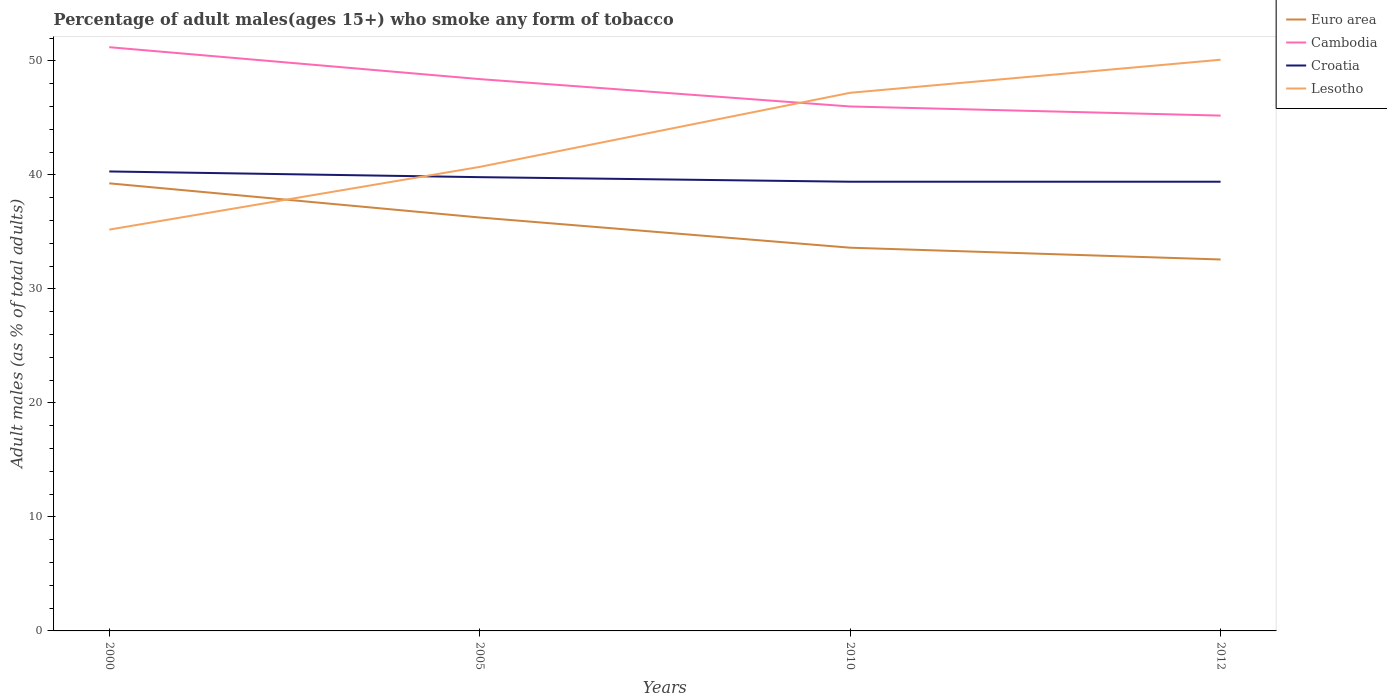Across all years, what is the maximum percentage of adult males who smoke in Croatia?
Offer a very short reply. 39.4. What is the total percentage of adult males who smoke in Cambodia in the graph?
Make the answer very short. 0.8. What is the difference between the highest and the second highest percentage of adult males who smoke in Croatia?
Keep it short and to the point. 0.9. Is the percentage of adult males who smoke in Croatia strictly greater than the percentage of adult males who smoke in Euro area over the years?
Your answer should be very brief. No. How many lines are there?
Ensure brevity in your answer.  4. How many years are there in the graph?
Your answer should be compact. 4. What is the difference between two consecutive major ticks on the Y-axis?
Ensure brevity in your answer.  10. Are the values on the major ticks of Y-axis written in scientific E-notation?
Give a very brief answer. No. How many legend labels are there?
Offer a terse response. 4. What is the title of the graph?
Ensure brevity in your answer.  Percentage of adult males(ages 15+) who smoke any form of tobacco. What is the label or title of the Y-axis?
Offer a terse response. Adult males (as % of total adults). What is the Adult males (as % of total adults) of Euro area in 2000?
Offer a terse response. 39.26. What is the Adult males (as % of total adults) in Cambodia in 2000?
Make the answer very short. 51.2. What is the Adult males (as % of total adults) in Croatia in 2000?
Your answer should be compact. 40.3. What is the Adult males (as % of total adults) of Lesotho in 2000?
Ensure brevity in your answer.  35.2. What is the Adult males (as % of total adults) of Euro area in 2005?
Your answer should be very brief. 36.26. What is the Adult males (as % of total adults) of Cambodia in 2005?
Your answer should be very brief. 48.4. What is the Adult males (as % of total adults) of Croatia in 2005?
Your answer should be compact. 39.8. What is the Adult males (as % of total adults) of Lesotho in 2005?
Offer a very short reply. 40.7. What is the Adult males (as % of total adults) of Euro area in 2010?
Give a very brief answer. 33.61. What is the Adult males (as % of total adults) in Croatia in 2010?
Your answer should be very brief. 39.4. What is the Adult males (as % of total adults) of Lesotho in 2010?
Your answer should be compact. 47.2. What is the Adult males (as % of total adults) of Euro area in 2012?
Offer a terse response. 32.58. What is the Adult males (as % of total adults) of Cambodia in 2012?
Offer a terse response. 45.2. What is the Adult males (as % of total adults) in Croatia in 2012?
Provide a short and direct response. 39.4. What is the Adult males (as % of total adults) of Lesotho in 2012?
Give a very brief answer. 50.1. Across all years, what is the maximum Adult males (as % of total adults) in Euro area?
Keep it short and to the point. 39.26. Across all years, what is the maximum Adult males (as % of total adults) of Cambodia?
Provide a succinct answer. 51.2. Across all years, what is the maximum Adult males (as % of total adults) in Croatia?
Your answer should be compact. 40.3. Across all years, what is the maximum Adult males (as % of total adults) in Lesotho?
Your answer should be very brief. 50.1. Across all years, what is the minimum Adult males (as % of total adults) of Euro area?
Provide a succinct answer. 32.58. Across all years, what is the minimum Adult males (as % of total adults) in Cambodia?
Your answer should be compact. 45.2. Across all years, what is the minimum Adult males (as % of total adults) in Croatia?
Your answer should be very brief. 39.4. Across all years, what is the minimum Adult males (as % of total adults) in Lesotho?
Provide a short and direct response. 35.2. What is the total Adult males (as % of total adults) of Euro area in the graph?
Your answer should be very brief. 141.71. What is the total Adult males (as % of total adults) of Cambodia in the graph?
Provide a succinct answer. 190.8. What is the total Adult males (as % of total adults) in Croatia in the graph?
Ensure brevity in your answer.  158.9. What is the total Adult males (as % of total adults) in Lesotho in the graph?
Provide a succinct answer. 173.2. What is the difference between the Adult males (as % of total adults) of Euro area in 2000 and that in 2005?
Offer a very short reply. 3. What is the difference between the Adult males (as % of total adults) of Croatia in 2000 and that in 2005?
Your response must be concise. 0.5. What is the difference between the Adult males (as % of total adults) in Euro area in 2000 and that in 2010?
Make the answer very short. 5.64. What is the difference between the Adult males (as % of total adults) of Euro area in 2000 and that in 2012?
Ensure brevity in your answer.  6.68. What is the difference between the Adult males (as % of total adults) of Croatia in 2000 and that in 2012?
Offer a terse response. 0.9. What is the difference between the Adult males (as % of total adults) of Lesotho in 2000 and that in 2012?
Make the answer very short. -14.9. What is the difference between the Adult males (as % of total adults) in Euro area in 2005 and that in 2010?
Your answer should be compact. 2.65. What is the difference between the Adult males (as % of total adults) in Cambodia in 2005 and that in 2010?
Provide a succinct answer. 2.4. What is the difference between the Adult males (as % of total adults) of Lesotho in 2005 and that in 2010?
Your response must be concise. -6.5. What is the difference between the Adult males (as % of total adults) of Euro area in 2005 and that in 2012?
Offer a terse response. 3.68. What is the difference between the Adult males (as % of total adults) of Croatia in 2005 and that in 2012?
Give a very brief answer. 0.4. What is the difference between the Adult males (as % of total adults) in Euro area in 2010 and that in 2012?
Your response must be concise. 1.03. What is the difference between the Adult males (as % of total adults) in Cambodia in 2010 and that in 2012?
Offer a very short reply. 0.8. What is the difference between the Adult males (as % of total adults) in Euro area in 2000 and the Adult males (as % of total adults) in Cambodia in 2005?
Make the answer very short. -9.14. What is the difference between the Adult males (as % of total adults) in Euro area in 2000 and the Adult males (as % of total adults) in Croatia in 2005?
Your answer should be compact. -0.54. What is the difference between the Adult males (as % of total adults) of Euro area in 2000 and the Adult males (as % of total adults) of Lesotho in 2005?
Provide a short and direct response. -1.44. What is the difference between the Adult males (as % of total adults) of Cambodia in 2000 and the Adult males (as % of total adults) of Croatia in 2005?
Provide a succinct answer. 11.4. What is the difference between the Adult males (as % of total adults) of Cambodia in 2000 and the Adult males (as % of total adults) of Lesotho in 2005?
Keep it short and to the point. 10.5. What is the difference between the Adult males (as % of total adults) of Croatia in 2000 and the Adult males (as % of total adults) of Lesotho in 2005?
Your response must be concise. -0.4. What is the difference between the Adult males (as % of total adults) of Euro area in 2000 and the Adult males (as % of total adults) of Cambodia in 2010?
Your answer should be compact. -6.74. What is the difference between the Adult males (as % of total adults) of Euro area in 2000 and the Adult males (as % of total adults) of Croatia in 2010?
Make the answer very short. -0.14. What is the difference between the Adult males (as % of total adults) of Euro area in 2000 and the Adult males (as % of total adults) of Lesotho in 2010?
Offer a terse response. -7.94. What is the difference between the Adult males (as % of total adults) of Cambodia in 2000 and the Adult males (as % of total adults) of Lesotho in 2010?
Give a very brief answer. 4. What is the difference between the Adult males (as % of total adults) in Croatia in 2000 and the Adult males (as % of total adults) in Lesotho in 2010?
Keep it short and to the point. -6.9. What is the difference between the Adult males (as % of total adults) of Euro area in 2000 and the Adult males (as % of total adults) of Cambodia in 2012?
Offer a very short reply. -5.94. What is the difference between the Adult males (as % of total adults) in Euro area in 2000 and the Adult males (as % of total adults) in Croatia in 2012?
Your answer should be very brief. -0.14. What is the difference between the Adult males (as % of total adults) in Euro area in 2000 and the Adult males (as % of total adults) in Lesotho in 2012?
Provide a short and direct response. -10.84. What is the difference between the Adult males (as % of total adults) of Croatia in 2000 and the Adult males (as % of total adults) of Lesotho in 2012?
Offer a terse response. -9.8. What is the difference between the Adult males (as % of total adults) of Euro area in 2005 and the Adult males (as % of total adults) of Cambodia in 2010?
Ensure brevity in your answer.  -9.74. What is the difference between the Adult males (as % of total adults) in Euro area in 2005 and the Adult males (as % of total adults) in Croatia in 2010?
Your answer should be very brief. -3.14. What is the difference between the Adult males (as % of total adults) of Euro area in 2005 and the Adult males (as % of total adults) of Lesotho in 2010?
Offer a very short reply. -10.94. What is the difference between the Adult males (as % of total adults) in Cambodia in 2005 and the Adult males (as % of total adults) in Croatia in 2010?
Your answer should be very brief. 9. What is the difference between the Adult males (as % of total adults) of Croatia in 2005 and the Adult males (as % of total adults) of Lesotho in 2010?
Provide a succinct answer. -7.4. What is the difference between the Adult males (as % of total adults) of Euro area in 2005 and the Adult males (as % of total adults) of Cambodia in 2012?
Your answer should be compact. -8.94. What is the difference between the Adult males (as % of total adults) of Euro area in 2005 and the Adult males (as % of total adults) of Croatia in 2012?
Your answer should be very brief. -3.14. What is the difference between the Adult males (as % of total adults) in Euro area in 2005 and the Adult males (as % of total adults) in Lesotho in 2012?
Provide a succinct answer. -13.84. What is the difference between the Adult males (as % of total adults) in Cambodia in 2005 and the Adult males (as % of total adults) in Croatia in 2012?
Your answer should be very brief. 9. What is the difference between the Adult males (as % of total adults) of Croatia in 2005 and the Adult males (as % of total adults) of Lesotho in 2012?
Your answer should be very brief. -10.3. What is the difference between the Adult males (as % of total adults) of Euro area in 2010 and the Adult males (as % of total adults) of Cambodia in 2012?
Provide a short and direct response. -11.59. What is the difference between the Adult males (as % of total adults) of Euro area in 2010 and the Adult males (as % of total adults) of Croatia in 2012?
Give a very brief answer. -5.79. What is the difference between the Adult males (as % of total adults) in Euro area in 2010 and the Adult males (as % of total adults) in Lesotho in 2012?
Your answer should be compact. -16.49. What is the difference between the Adult males (as % of total adults) of Cambodia in 2010 and the Adult males (as % of total adults) of Croatia in 2012?
Provide a short and direct response. 6.6. What is the difference between the Adult males (as % of total adults) in Cambodia in 2010 and the Adult males (as % of total adults) in Lesotho in 2012?
Provide a short and direct response. -4.1. What is the average Adult males (as % of total adults) of Euro area per year?
Ensure brevity in your answer.  35.43. What is the average Adult males (as % of total adults) of Cambodia per year?
Keep it short and to the point. 47.7. What is the average Adult males (as % of total adults) in Croatia per year?
Offer a very short reply. 39.73. What is the average Adult males (as % of total adults) in Lesotho per year?
Your response must be concise. 43.3. In the year 2000, what is the difference between the Adult males (as % of total adults) of Euro area and Adult males (as % of total adults) of Cambodia?
Provide a short and direct response. -11.94. In the year 2000, what is the difference between the Adult males (as % of total adults) of Euro area and Adult males (as % of total adults) of Croatia?
Offer a terse response. -1.04. In the year 2000, what is the difference between the Adult males (as % of total adults) in Euro area and Adult males (as % of total adults) in Lesotho?
Offer a terse response. 4.06. In the year 2000, what is the difference between the Adult males (as % of total adults) of Croatia and Adult males (as % of total adults) of Lesotho?
Give a very brief answer. 5.1. In the year 2005, what is the difference between the Adult males (as % of total adults) in Euro area and Adult males (as % of total adults) in Cambodia?
Give a very brief answer. -12.14. In the year 2005, what is the difference between the Adult males (as % of total adults) in Euro area and Adult males (as % of total adults) in Croatia?
Provide a succinct answer. -3.54. In the year 2005, what is the difference between the Adult males (as % of total adults) of Euro area and Adult males (as % of total adults) of Lesotho?
Keep it short and to the point. -4.44. In the year 2005, what is the difference between the Adult males (as % of total adults) of Cambodia and Adult males (as % of total adults) of Croatia?
Give a very brief answer. 8.6. In the year 2005, what is the difference between the Adult males (as % of total adults) in Cambodia and Adult males (as % of total adults) in Lesotho?
Your response must be concise. 7.7. In the year 2010, what is the difference between the Adult males (as % of total adults) in Euro area and Adult males (as % of total adults) in Cambodia?
Provide a succinct answer. -12.39. In the year 2010, what is the difference between the Adult males (as % of total adults) in Euro area and Adult males (as % of total adults) in Croatia?
Provide a succinct answer. -5.79. In the year 2010, what is the difference between the Adult males (as % of total adults) in Euro area and Adult males (as % of total adults) in Lesotho?
Offer a very short reply. -13.59. In the year 2010, what is the difference between the Adult males (as % of total adults) of Croatia and Adult males (as % of total adults) of Lesotho?
Provide a succinct answer. -7.8. In the year 2012, what is the difference between the Adult males (as % of total adults) in Euro area and Adult males (as % of total adults) in Cambodia?
Provide a short and direct response. -12.62. In the year 2012, what is the difference between the Adult males (as % of total adults) in Euro area and Adult males (as % of total adults) in Croatia?
Ensure brevity in your answer.  -6.82. In the year 2012, what is the difference between the Adult males (as % of total adults) of Euro area and Adult males (as % of total adults) of Lesotho?
Make the answer very short. -17.52. In the year 2012, what is the difference between the Adult males (as % of total adults) of Croatia and Adult males (as % of total adults) of Lesotho?
Your answer should be compact. -10.7. What is the ratio of the Adult males (as % of total adults) in Euro area in 2000 to that in 2005?
Give a very brief answer. 1.08. What is the ratio of the Adult males (as % of total adults) of Cambodia in 2000 to that in 2005?
Your answer should be compact. 1.06. What is the ratio of the Adult males (as % of total adults) of Croatia in 2000 to that in 2005?
Give a very brief answer. 1.01. What is the ratio of the Adult males (as % of total adults) of Lesotho in 2000 to that in 2005?
Provide a short and direct response. 0.86. What is the ratio of the Adult males (as % of total adults) of Euro area in 2000 to that in 2010?
Give a very brief answer. 1.17. What is the ratio of the Adult males (as % of total adults) of Cambodia in 2000 to that in 2010?
Offer a terse response. 1.11. What is the ratio of the Adult males (as % of total adults) of Croatia in 2000 to that in 2010?
Your answer should be compact. 1.02. What is the ratio of the Adult males (as % of total adults) of Lesotho in 2000 to that in 2010?
Your answer should be very brief. 0.75. What is the ratio of the Adult males (as % of total adults) of Euro area in 2000 to that in 2012?
Offer a terse response. 1.21. What is the ratio of the Adult males (as % of total adults) of Cambodia in 2000 to that in 2012?
Give a very brief answer. 1.13. What is the ratio of the Adult males (as % of total adults) of Croatia in 2000 to that in 2012?
Provide a succinct answer. 1.02. What is the ratio of the Adult males (as % of total adults) of Lesotho in 2000 to that in 2012?
Your answer should be compact. 0.7. What is the ratio of the Adult males (as % of total adults) of Euro area in 2005 to that in 2010?
Provide a succinct answer. 1.08. What is the ratio of the Adult males (as % of total adults) in Cambodia in 2005 to that in 2010?
Provide a short and direct response. 1.05. What is the ratio of the Adult males (as % of total adults) in Croatia in 2005 to that in 2010?
Keep it short and to the point. 1.01. What is the ratio of the Adult males (as % of total adults) of Lesotho in 2005 to that in 2010?
Offer a terse response. 0.86. What is the ratio of the Adult males (as % of total adults) in Euro area in 2005 to that in 2012?
Offer a very short reply. 1.11. What is the ratio of the Adult males (as % of total adults) of Cambodia in 2005 to that in 2012?
Offer a very short reply. 1.07. What is the ratio of the Adult males (as % of total adults) of Croatia in 2005 to that in 2012?
Your answer should be very brief. 1.01. What is the ratio of the Adult males (as % of total adults) of Lesotho in 2005 to that in 2012?
Make the answer very short. 0.81. What is the ratio of the Adult males (as % of total adults) of Euro area in 2010 to that in 2012?
Provide a succinct answer. 1.03. What is the ratio of the Adult males (as % of total adults) in Cambodia in 2010 to that in 2012?
Provide a succinct answer. 1.02. What is the ratio of the Adult males (as % of total adults) of Lesotho in 2010 to that in 2012?
Make the answer very short. 0.94. What is the difference between the highest and the second highest Adult males (as % of total adults) in Euro area?
Your answer should be compact. 3. What is the difference between the highest and the second highest Adult males (as % of total adults) in Lesotho?
Your response must be concise. 2.9. What is the difference between the highest and the lowest Adult males (as % of total adults) in Euro area?
Provide a succinct answer. 6.68. What is the difference between the highest and the lowest Adult males (as % of total adults) of Croatia?
Ensure brevity in your answer.  0.9. What is the difference between the highest and the lowest Adult males (as % of total adults) of Lesotho?
Provide a succinct answer. 14.9. 